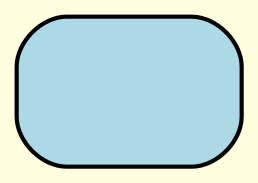What is the root cause of the decision tree? The root of the decision tree states "Complex software bug detected", indicating that the primary focus is on debugging a software issue.
Answer: Complex software bug detected How many main branches are there in the diagram? Upon examining the structure of the diagram, there are three main branches extending from the root: Check error logs, Review recent code changes, and Reproduce bug in test environment.
Answer: 3 What is the outcome of verifying database credentials when they are correct? The decision tree outlines that if the credentials are confirmed to be correct after verification, the next step indicates to "Investigate further" to pinpoint the issue.
Answer: Investigate further What should you do if the bug is reproduced in the test environment? The decision tree specifies that if the bug is reproduced in the test environment, the next action should involve "Isolate affected components" or "Add logging statements".
Answer: Isolate affected components What happens if a new feature implementation is not causing the issue? According to the decision tree, if the new feature implementation is found not to cause the issue, the next step suggests to "Investigate further" to look for other causes.
Answer: Investigate further What node follows a "Memory leak detected" in the decision tree? After the "Memory leak detected" node, the next step in the decision tree is to "Profile memory usage", further analyzing the memory concerning the bug.
Answer: Profile memory usage If there is a problem with a third-party library, what immediate action should be taken based on the decision tree? The diagram indicates that if there is an issue with a third-party library, the first immediate action should be to "Downgrade library", which may resolve the bug.
Answer: Downgrade library What does it imply when no bug is reproduced? The decision tree guides that if the bug cannot be reproduced in the testing environment, it implies the need to "Check environment differences" for potential causes.
Answer: Check environment differences What outcome arises from optimizing resource allocation? The decision tree shows that if you optimize resource allocation in response to a memory leak, the outcome is "Bug resolved", indicating a successful fix.
Answer: Bug resolved 